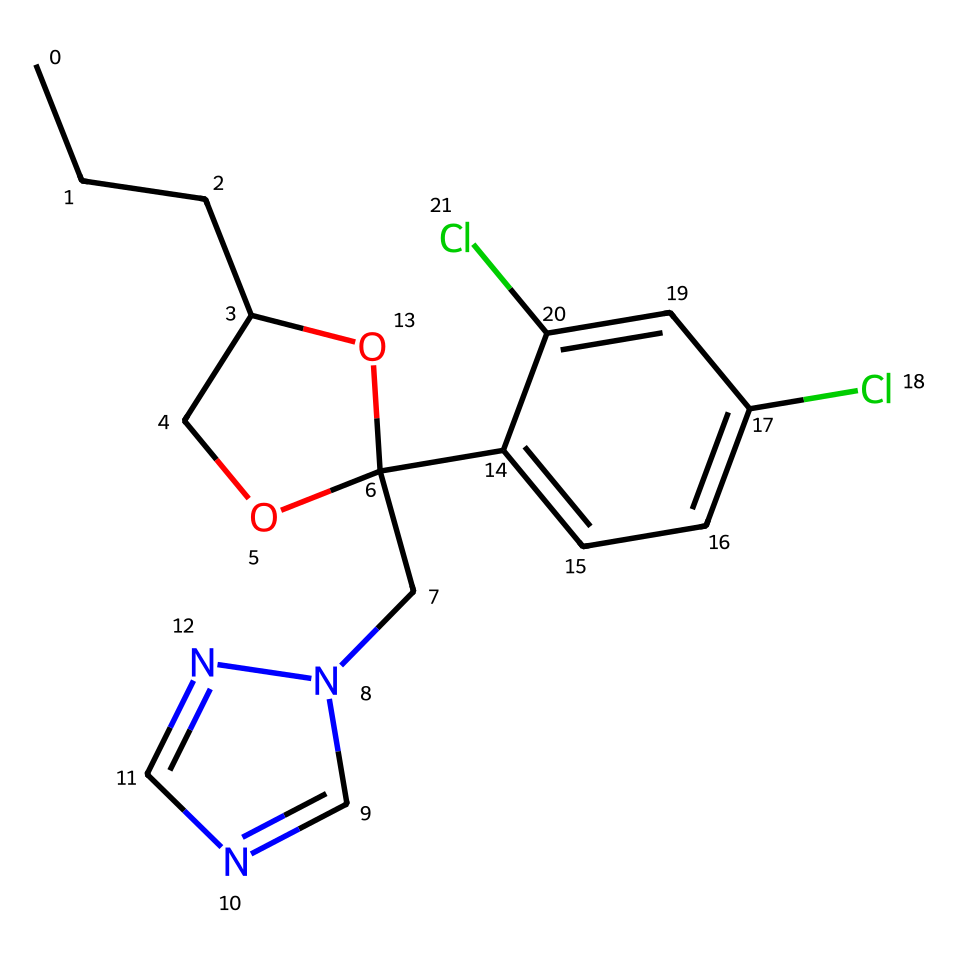What is the name of this fungicide? The SMILES representation indicates that the structure corresponds to propiconazole, which is a recognized fungicide.
Answer: propiconazole How many chlorine atoms are in the structure? By examining the SMILES code, we identify two occurrences of 'Cl', indicating the presence of two chlorine atoms.
Answer: two What functional groups are present in propiconazole? The SMILES shows a hydroxyl group (-OH) represented as 'O' next to a carbon in the ring structure, indicating a phenolic function, as well as the presence of a pyrimidine ring.
Answer: hydroxyl and pyrimidine What is the molecular formula of propiconazole? By analyzing the number of each type of atom in the SMILES, we can derive the molecular formula C13H16Cl2N2O, accounting for all the carbon, hydrogen, chlorine, nitrogen, and oxygen atoms present.
Answer: C13H16Cl2N2O Is propiconazole considered a systemic fungicide? Propiconazole is designed to be absorbed and distributed throughout the plant system, making it a systemic fungicide, effective against fungi in various infected tissues.
Answer: yes What type of bond is primarily present in the chemical structure of propiconazole? The structure involves many carbon-carbon (C-C) and carbon-nitrogen (C-N) bonds, but the primary bond type visible throughout is covalent, characteristic in organic compounds.
Answer: covalent How many rings are present in the structure? The SMILES reveals that there is one aromatic ring along with a heterocyclic ring, giving a total of two rings in the structure of propiconazole.
Answer: two 